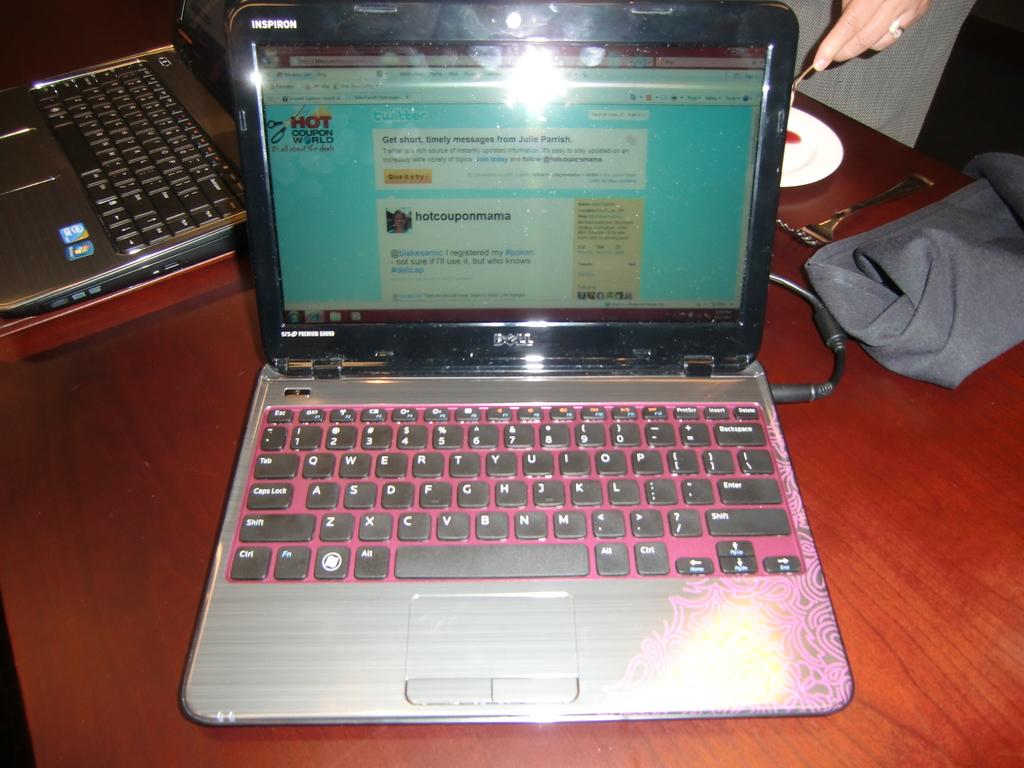What is the big red word on the top right of monitor screen?
Offer a terse response. Hot. What brand is this computer?
Offer a terse response. Dell. 